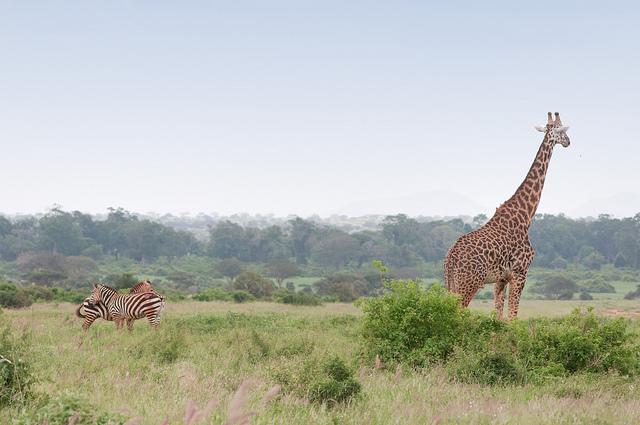How many giraffe are standing in the field?
Concise answer only. 1. Is the giraffe mad at the zebra?
Answer briefly. No. What are the smaller animals to the left?
Be succinct. Zebras. 